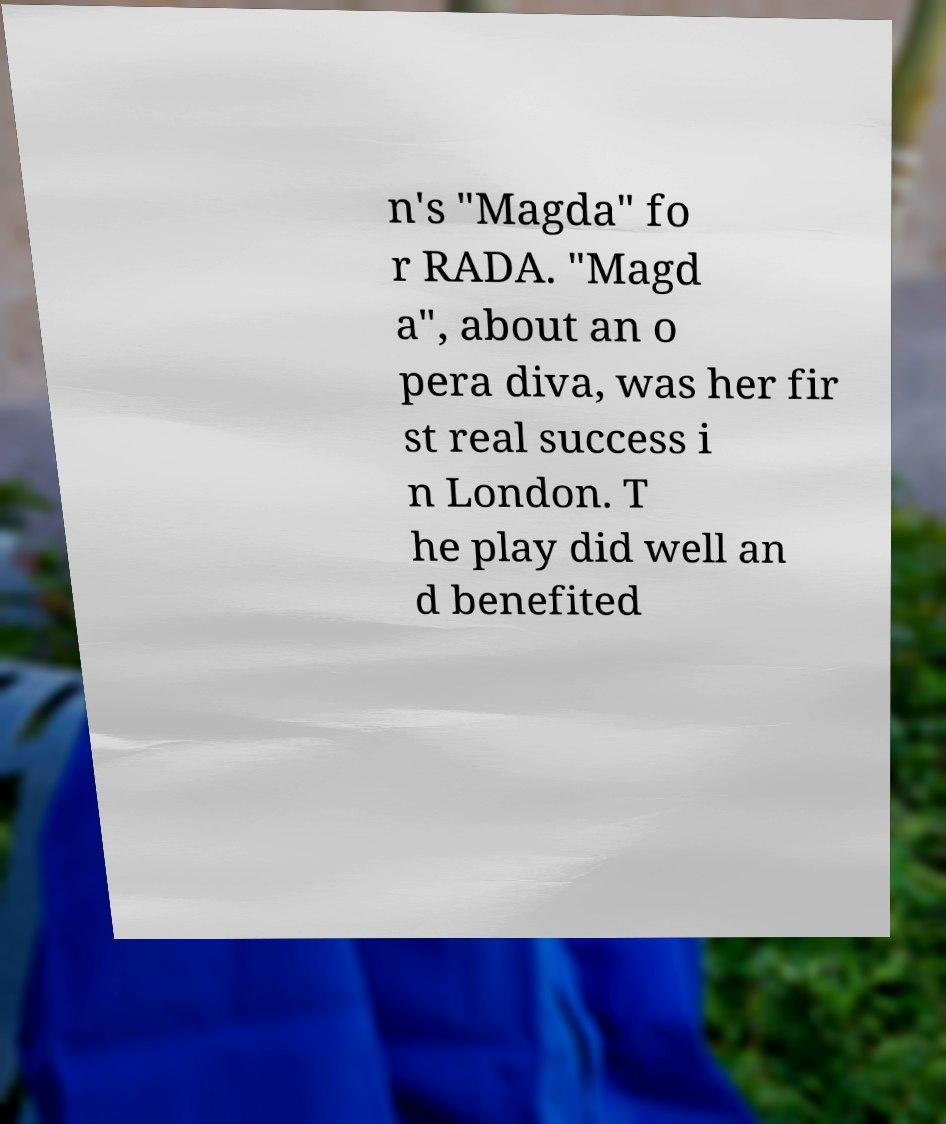Can you read and provide the text displayed in the image?This photo seems to have some interesting text. Can you extract and type it out for me? n's "Magda" fo r RADA. "Magd a", about an o pera diva, was her fir st real success i n London. T he play did well an d benefited 